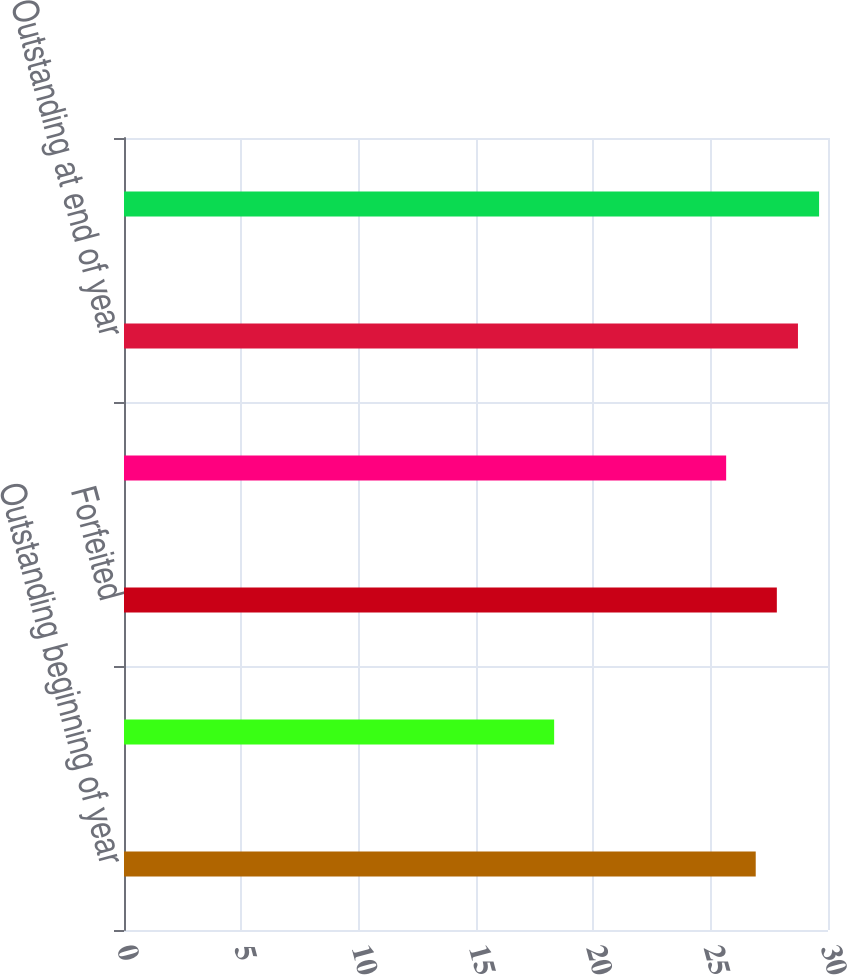<chart> <loc_0><loc_0><loc_500><loc_500><bar_chart><fcel>Outstanding beginning of year<fcel>Exercised<fcel>Forfeited<fcel>Expired<fcel>Outstanding at end of year<fcel>Exercisable at end of year<nl><fcel>26.92<fcel>18.33<fcel>27.82<fcel>25.66<fcel>28.72<fcel>29.62<nl></chart> 